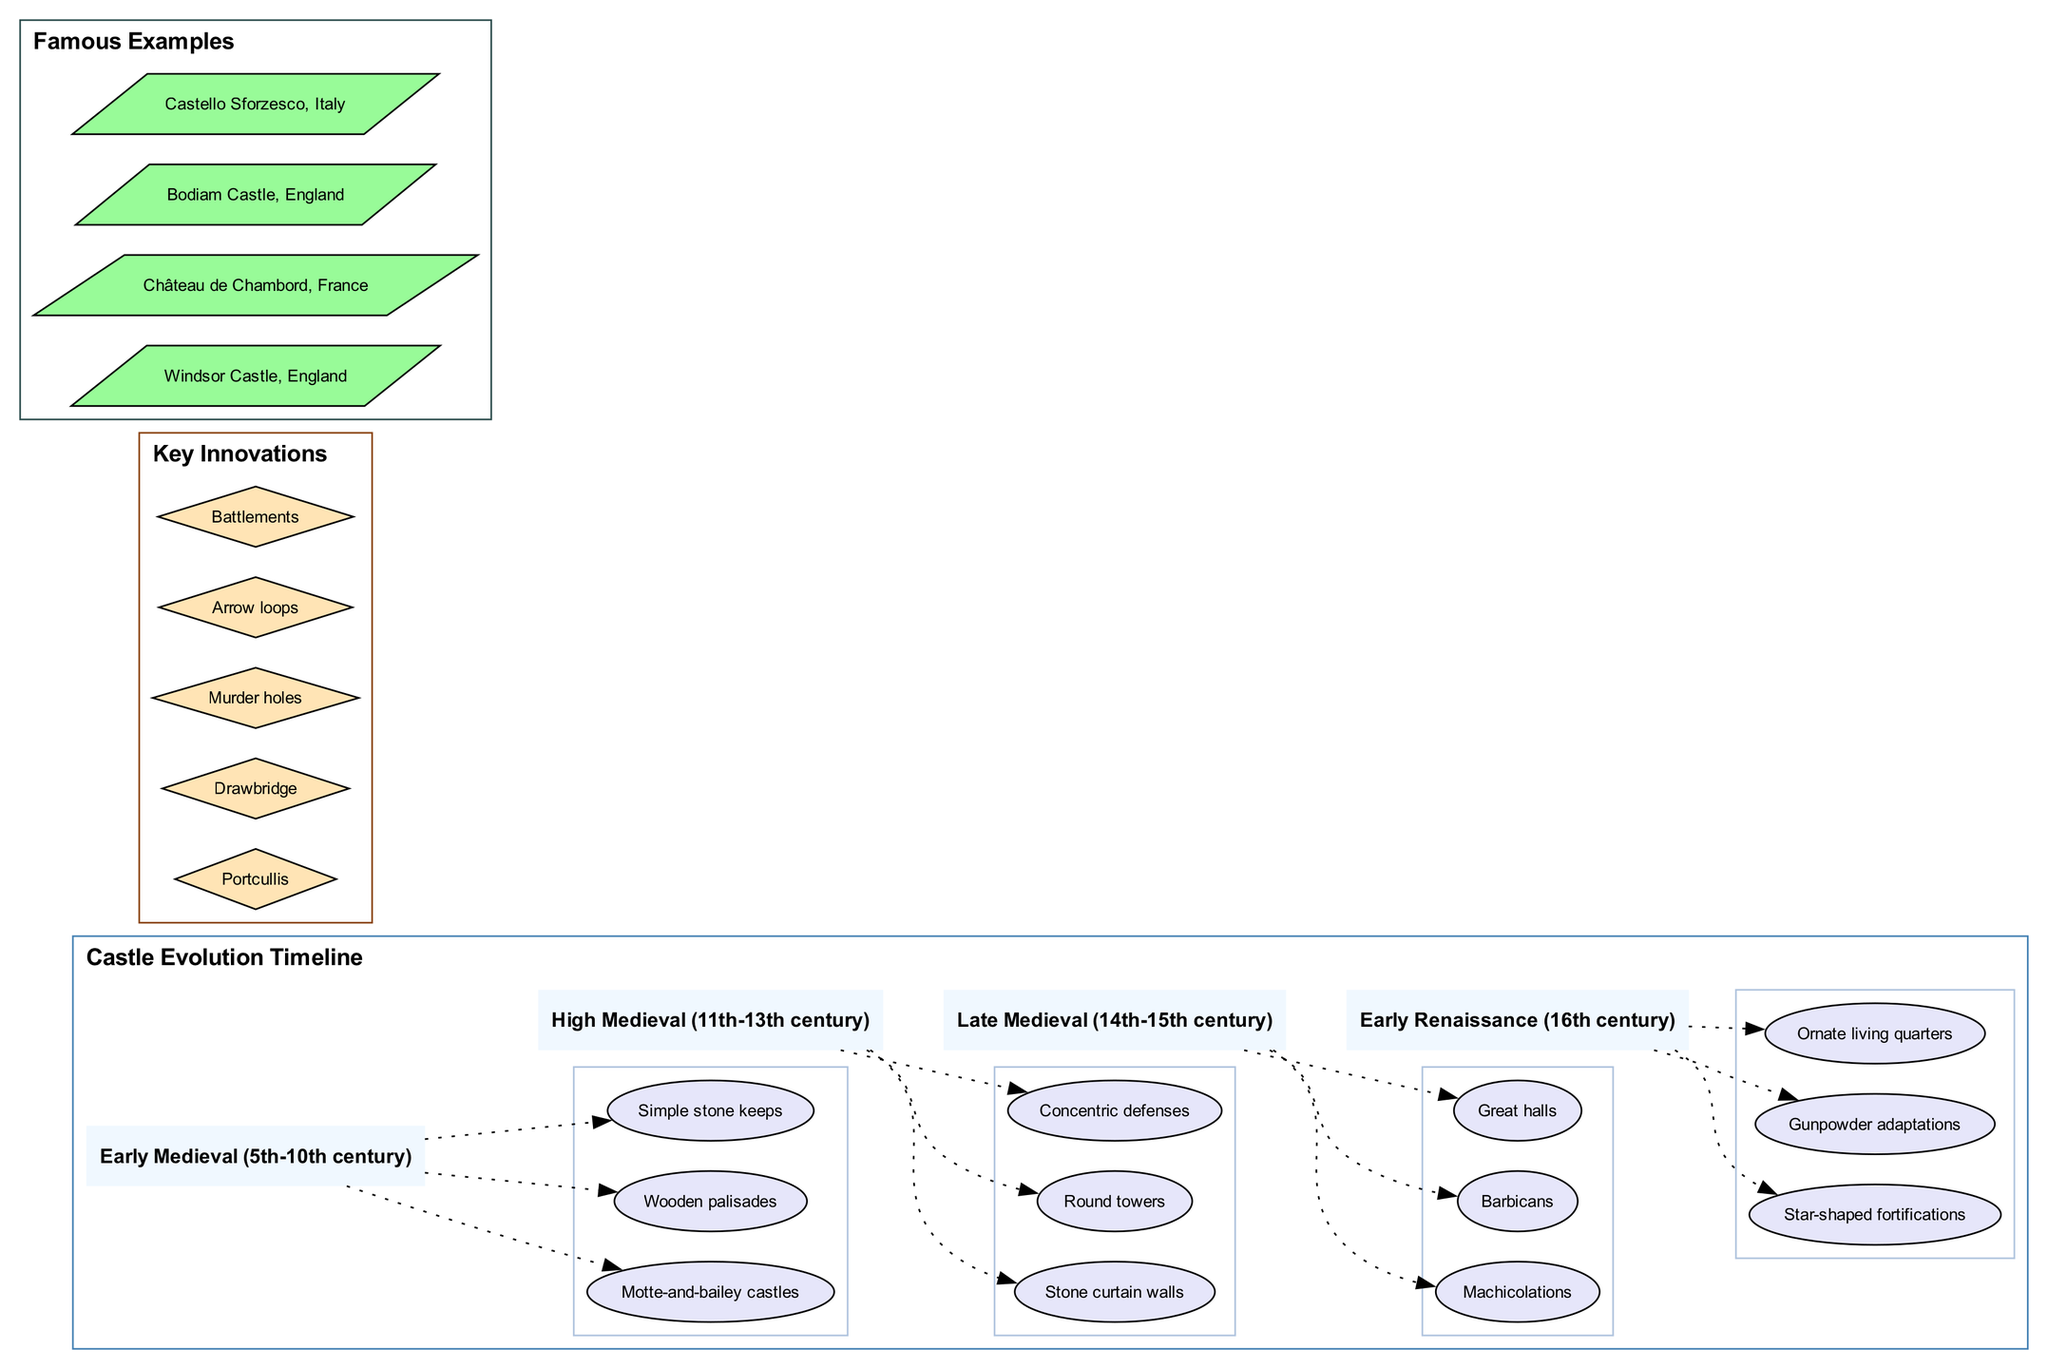What period comes after the High Medieval? The timeline indicates that the period after the High Medieval (11th-13th century) is the Late Medieval (14th-15th century). This connection is made by looking at the sequence of periods listed in the diagram.
Answer: Late Medieval How many features are listed for the Early Medieval period? By examining the Early Medieval section, there are three features specifically mentioned: motte-and-bailey castles, wooden palisades, and simple stone keeps. Therefore, the count of features is three.
Answer: 3 Which castle represents an example from Italy? In the famous examples section of the diagram, Castello Sforzesco is listed, indicating that it is an example from Italy. Thus, the answer is based on finding and identifying the location associated with the mentioned castle.
Answer: Castello Sforzesco What type of fortifications emerged in the Early Renaissance? The Early Renaissance period is noted for star-shaped fortifications, which is specified in the features list for that period. This requires identifying the unique architectural style linked to the Early Renaissance listed in the diagram.
Answer: Star-shaped fortifications Which key innovation is a method of entry? The diagram lists "Drawbridge" among the key innovations, which is specifically designed for entry into and out of a castle. To answer, one would locate the innovation within the key innovations cluster that pertains to entry methods.
Answer: Drawbridge What feature is common to Late Medieval castles? The diagram indicates that Late Medieval castles featured machicolations, barbicans, and great halls. Among these, great halls are notable, signifying their importance and commonality during that period. Thus, one can identify great halls directly from that specific period's list.
Answer: Great halls Which period is characterized by gunpowder adaptations? The Early Renaissance period is characterized by gunpowder adaptations, as explicitly stated in the features for that time. By looking at the features listed under that period, we can directly draw this conclusion.
Answer: Early Renaissance How many key innovations are mentioned in total? The key innovations section lists five innovations: portcullis, drawbridge, murder holes, arrow loops, and battlements. Counting each of these innovations provides the total count, leading to the answer.
Answer: 5 What defensive feature is found in High Medieval castles? High Medieval castles feature round towers according to the timeline. By identifying the listed features under the High Medieval section, one can easily discern which defensive features were common in that period.
Answer: Round towers 